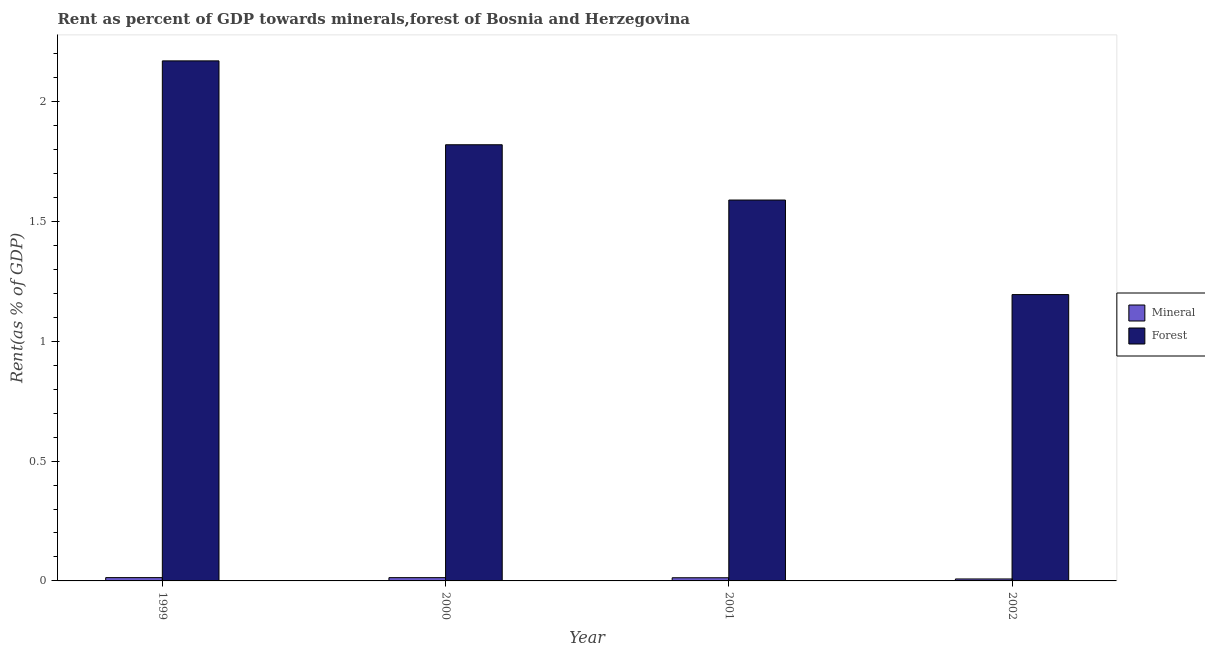How many different coloured bars are there?
Offer a very short reply. 2. How many bars are there on the 3rd tick from the left?
Ensure brevity in your answer.  2. How many bars are there on the 4th tick from the right?
Offer a very short reply. 2. What is the label of the 1st group of bars from the left?
Provide a short and direct response. 1999. What is the forest rent in 2000?
Your answer should be very brief. 1.82. Across all years, what is the maximum forest rent?
Make the answer very short. 2.17. Across all years, what is the minimum forest rent?
Ensure brevity in your answer.  1.19. What is the total forest rent in the graph?
Offer a very short reply. 6.77. What is the difference between the forest rent in 1999 and that in 2000?
Your answer should be very brief. 0.35. What is the difference between the mineral rent in 2000 and the forest rent in 1999?
Offer a terse response. -9.625985984700047e-5. What is the average mineral rent per year?
Your answer should be very brief. 0.01. In the year 2002, what is the difference between the forest rent and mineral rent?
Provide a succinct answer. 0. In how many years, is the mineral rent greater than 0.2 %?
Ensure brevity in your answer.  0. What is the ratio of the forest rent in 2000 to that in 2002?
Your answer should be very brief. 1.52. Is the mineral rent in 2000 less than that in 2001?
Offer a very short reply. No. What is the difference between the highest and the second highest mineral rent?
Your response must be concise. 9.625985984700047e-5. What is the difference between the highest and the lowest mineral rent?
Offer a terse response. 0.01. In how many years, is the forest rent greater than the average forest rent taken over all years?
Your response must be concise. 2. What does the 2nd bar from the left in 2002 represents?
Provide a succinct answer. Forest. What does the 2nd bar from the right in 2002 represents?
Make the answer very short. Mineral. What is the difference between two consecutive major ticks on the Y-axis?
Ensure brevity in your answer.  0.5. Does the graph contain any zero values?
Offer a terse response. No. Does the graph contain grids?
Your response must be concise. No. How many legend labels are there?
Make the answer very short. 2. How are the legend labels stacked?
Ensure brevity in your answer.  Vertical. What is the title of the graph?
Give a very brief answer. Rent as percent of GDP towards minerals,forest of Bosnia and Herzegovina. What is the label or title of the Y-axis?
Keep it short and to the point. Rent(as % of GDP). What is the Rent(as % of GDP) in Mineral in 1999?
Make the answer very short. 0.01. What is the Rent(as % of GDP) of Forest in 1999?
Your response must be concise. 2.17. What is the Rent(as % of GDP) in Mineral in 2000?
Provide a short and direct response. 0.01. What is the Rent(as % of GDP) of Forest in 2000?
Your answer should be compact. 1.82. What is the Rent(as % of GDP) in Mineral in 2001?
Provide a short and direct response. 0.01. What is the Rent(as % of GDP) in Forest in 2001?
Provide a succinct answer. 1.59. What is the Rent(as % of GDP) in Mineral in 2002?
Provide a short and direct response. 0.01. What is the Rent(as % of GDP) of Forest in 2002?
Offer a terse response. 1.19. Across all years, what is the maximum Rent(as % of GDP) of Mineral?
Your answer should be very brief. 0.01. Across all years, what is the maximum Rent(as % of GDP) of Forest?
Offer a terse response. 2.17. Across all years, what is the minimum Rent(as % of GDP) of Mineral?
Provide a succinct answer. 0.01. Across all years, what is the minimum Rent(as % of GDP) of Forest?
Give a very brief answer. 1.19. What is the total Rent(as % of GDP) of Mineral in the graph?
Your answer should be very brief. 0.05. What is the total Rent(as % of GDP) in Forest in the graph?
Your response must be concise. 6.77. What is the difference between the Rent(as % of GDP) in Forest in 1999 and that in 2000?
Your response must be concise. 0.35. What is the difference between the Rent(as % of GDP) of Mineral in 1999 and that in 2001?
Give a very brief answer. 0. What is the difference between the Rent(as % of GDP) in Forest in 1999 and that in 2001?
Provide a succinct answer. 0.58. What is the difference between the Rent(as % of GDP) of Mineral in 1999 and that in 2002?
Make the answer very short. 0.01. What is the difference between the Rent(as % of GDP) in Forest in 1999 and that in 2002?
Your answer should be very brief. 0.98. What is the difference between the Rent(as % of GDP) in Forest in 2000 and that in 2001?
Offer a very short reply. 0.23. What is the difference between the Rent(as % of GDP) of Mineral in 2000 and that in 2002?
Give a very brief answer. 0.01. What is the difference between the Rent(as % of GDP) in Forest in 2000 and that in 2002?
Keep it short and to the point. 0.63. What is the difference between the Rent(as % of GDP) in Mineral in 2001 and that in 2002?
Your response must be concise. 0.01. What is the difference between the Rent(as % of GDP) in Forest in 2001 and that in 2002?
Keep it short and to the point. 0.39. What is the difference between the Rent(as % of GDP) in Mineral in 1999 and the Rent(as % of GDP) in Forest in 2000?
Offer a very short reply. -1.81. What is the difference between the Rent(as % of GDP) of Mineral in 1999 and the Rent(as % of GDP) of Forest in 2001?
Give a very brief answer. -1.58. What is the difference between the Rent(as % of GDP) of Mineral in 1999 and the Rent(as % of GDP) of Forest in 2002?
Give a very brief answer. -1.18. What is the difference between the Rent(as % of GDP) of Mineral in 2000 and the Rent(as % of GDP) of Forest in 2001?
Your response must be concise. -1.58. What is the difference between the Rent(as % of GDP) of Mineral in 2000 and the Rent(as % of GDP) of Forest in 2002?
Offer a very short reply. -1.18. What is the difference between the Rent(as % of GDP) in Mineral in 2001 and the Rent(as % of GDP) in Forest in 2002?
Offer a terse response. -1.18. What is the average Rent(as % of GDP) in Mineral per year?
Offer a terse response. 0.01. What is the average Rent(as % of GDP) of Forest per year?
Offer a very short reply. 1.69. In the year 1999, what is the difference between the Rent(as % of GDP) of Mineral and Rent(as % of GDP) of Forest?
Offer a terse response. -2.16. In the year 2000, what is the difference between the Rent(as % of GDP) of Mineral and Rent(as % of GDP) of Forest?
Provide a short and direct response. -1.81. In the year 2001, what is the difference between the Rent(as % of GDP) of Mineral and Rent(as % of GDP) of Forest?
Give a very brief answer. -1.58. In the year 2002, what is the difference between the Rent(as % of GDP) of Mineral and Rent(as % of GDP) of Forest?
Provide a short and direct response. -1.19. What is the ratio of the Rent(as % of GDP) of Forest in 1999 to that in 2000?
Make the answer very short. 1.19. What is the ratio of the Rent(as % of GDP) in Mineral in 1999 to that in 2001?
Ensure brevity in your answer.  1.04. What is the ratio of the Rent(as % of GDP) in Forest in 1999 to that in 2001?
Your answer should be compact. 1.37. What is the ratio of the Rent(as % of GDP) in Mineral in 1999 to that in 2002?
Keep it short and to the point. 1.68. What is the ratio of the Rent(as % of GDP) of Forest in 1999 to that in 2002?
Provide a short and direct response. 1.82. What is the ratio of the Rent(as % of GDP) in Mineral in 2000 to that in 2001?
Offer a very short reply. 1.04. What is the ratio of the Rent(as % of GDP) in Forest in 2000 to that in 2001?
Provide a succinct answer. 1.15. What is the ratio of the Rent(as % of GDP) in Mineral in 2000 to that in 2002?
Keep it short and to the point. 1.67. What is the ratio of the Rent(as % of GDP) in Forest in 2000 to that in 2002?
Offer a terse response. 1.52. What is the ratio of the Rent(as % of GDP) in Mineral in 2001 to that in 2002?
Provide a succinct answer. 1.61. What is the ratio of the Rent(as % of GDP) of Forest in 2001 to that in 2002?
Keep it short and to the point. 1.33. What is the difference between the highest and the second highest Rent(as % of GDP) in Forest?
Give a very brief answer. 0.35. What is the difference between the highest and the lowest Rent(as % of GDP) of Mineral?
Provide a succinct answer. 0.01. What is the difference between the highest and the lowest Rent(as % of GDP) of Forest?
Keep it short and to the point. 0.98. 